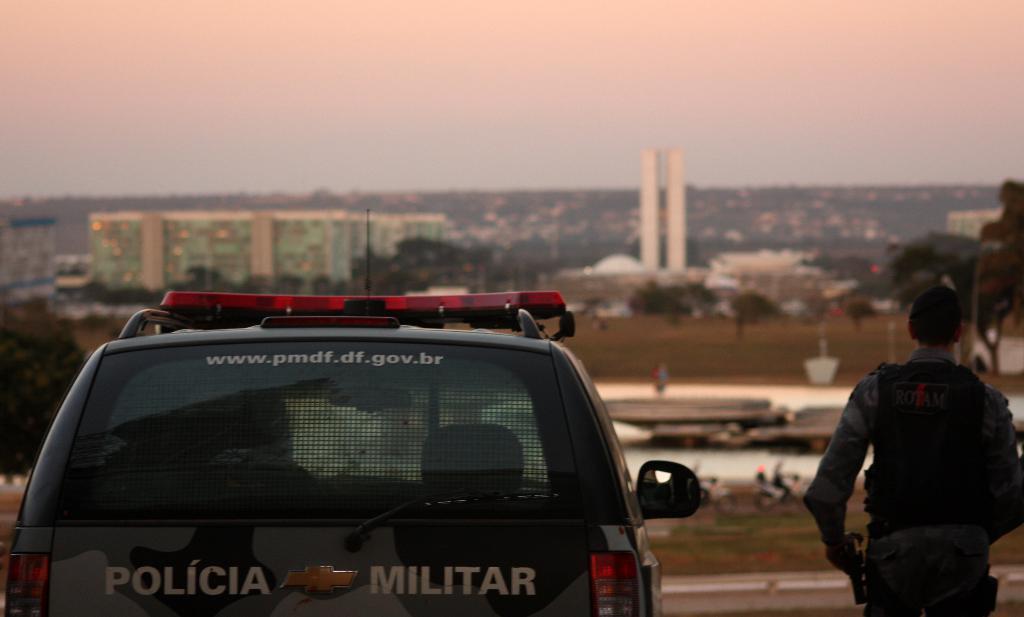Could you give a brief overview of what you see in this image? On the left there is a vehicle and on the right there is a man standing. In the background we can see buildings,trees and sky. 